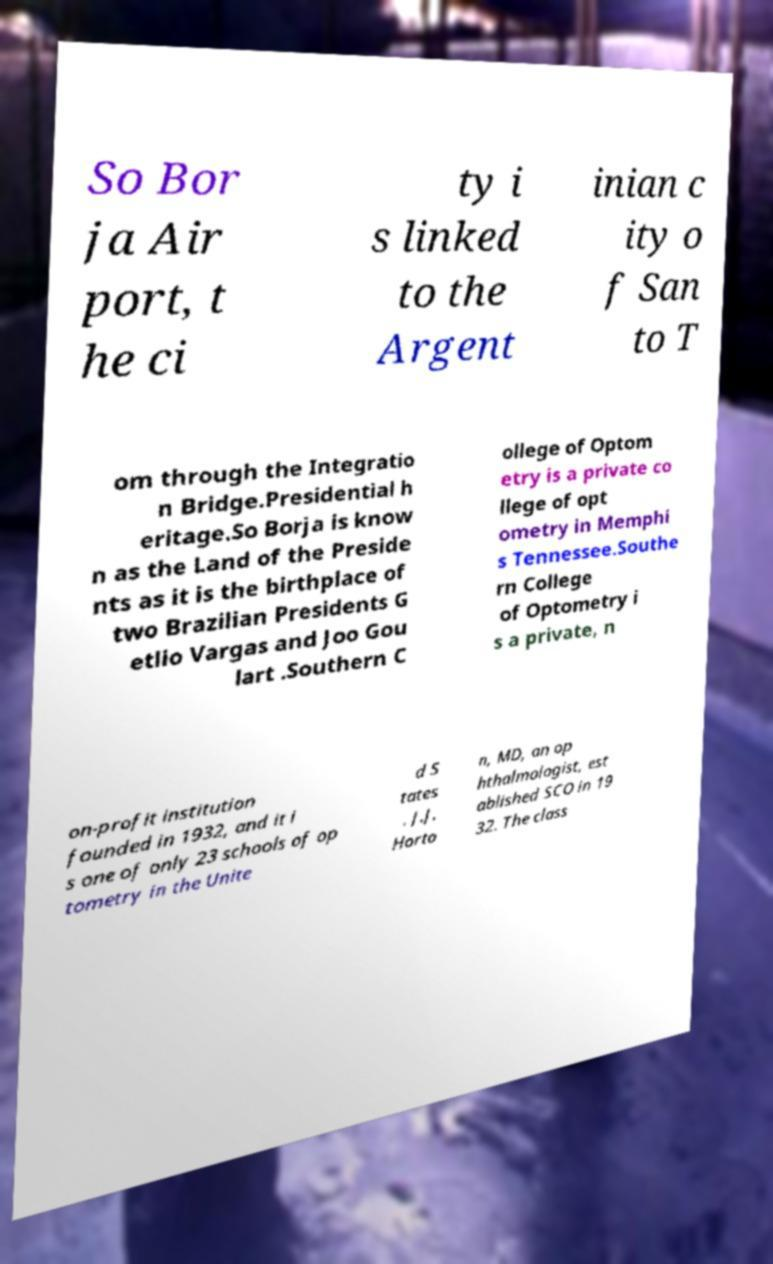Can you read and provide the text displayed in the image?This photo seems to have some interesting text. Can you extract and type it out for me? So Bor ja Air port, t he ci ty i s linked to the Argent inian c ity o f San to T om through the Integratio n Bridge.Presidential h eritage.So Borja is know n as the Land of the Preside nts as it is the birthplace of two Brazilian Presidents G etlio Vargas and Joo Gou lart .Southern C ollege of Optom etry is a private co llege of opt ometry in Memphi s Tennessee.Southe rn College of Optometry i s a private, n on-profit institution founded in 1932, and it i s one of only 23 schools of op tometry in the Unite d S tates . J.J. Horto n, MD, an op hthalmologist, est ablished SCO in 19 32. The class 